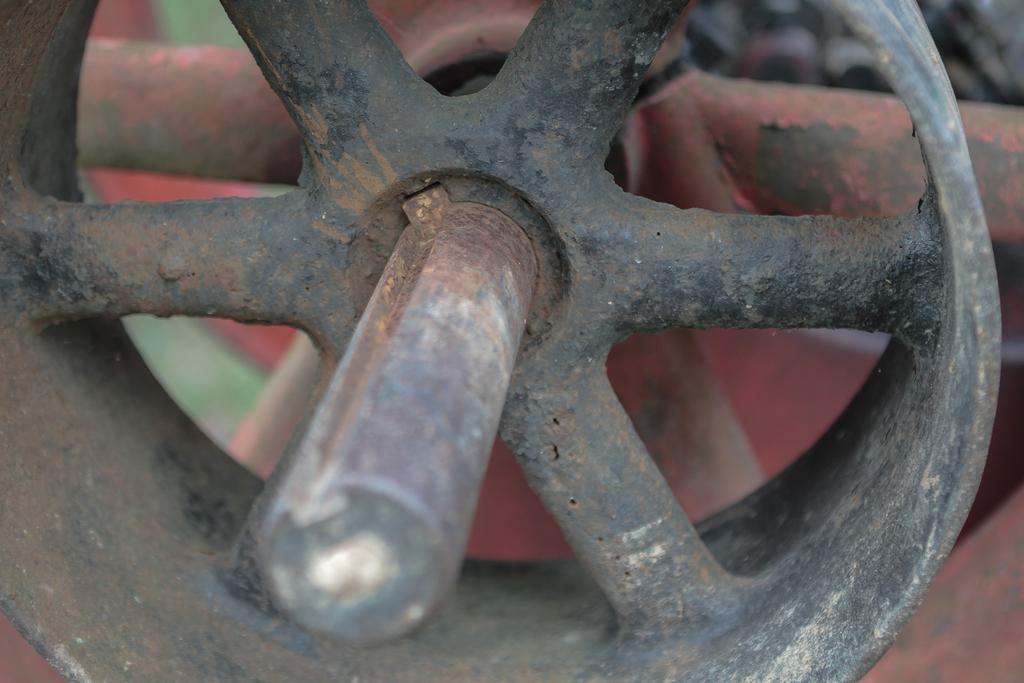What is the main subject in the center of the image? There is a black wheel in the center of the image. What other wheels can be seen in the image? There is a red and green wheel in the background of the image. How many firemen are present in the image? There is no mention of firemen or any people in the image; it only features two wheels. 